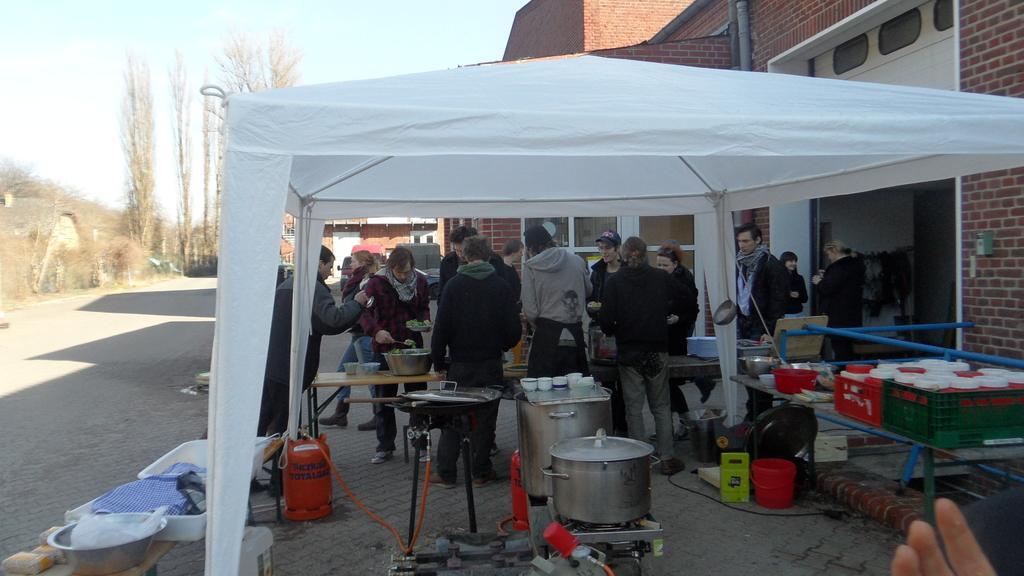In one or two sentences, can you explain what this image depicts? In the front of the image I can see a white tent. Under the tent there are people, tables, cylinders, pipe, containers, baskets, bucket and objects. In the background of the image there are buildings, trees, vehicles and sky. 